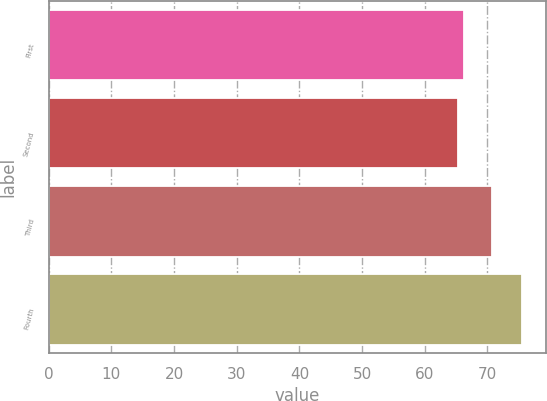Convert chart to OTSL. <chart><loc_0><loc_0><loc_500><loc_500><bar_chart><fcel>First<fcel>Second<fcel>Third<fcel>Fourth<nl><fcel>66.34<fcel>65.31<fcel>70.71<fcel>75.6<nl></chart> 